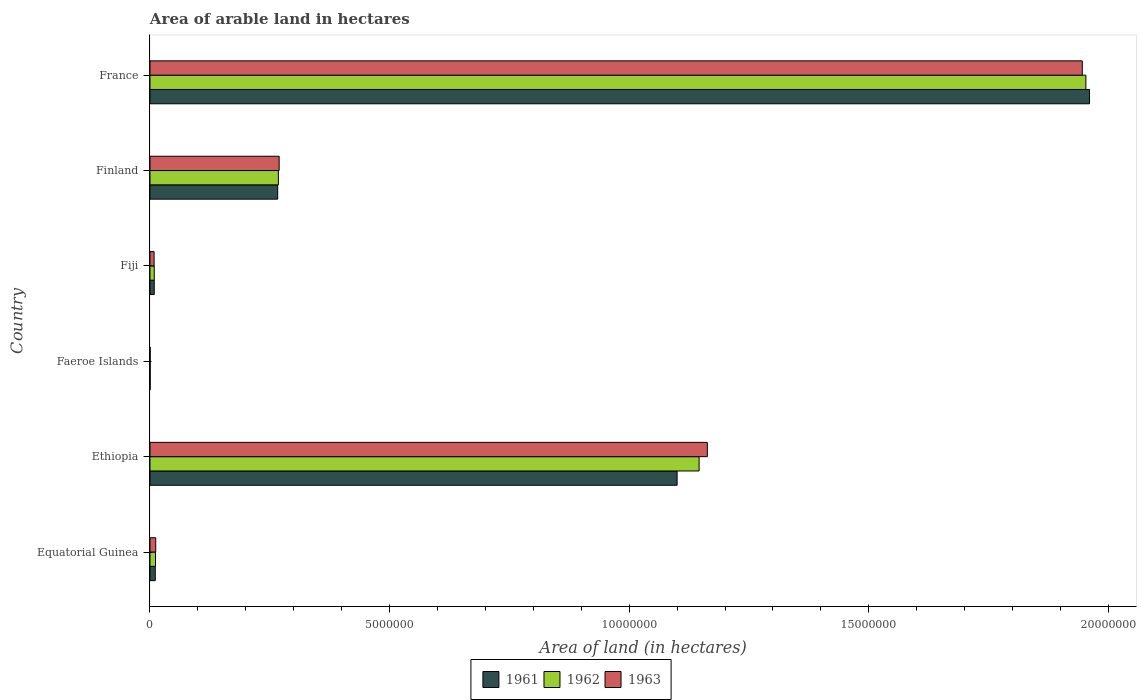How many different coloured bars are there?
Your answer should be compact. 3. How many groups of bars are there?
Provide a short and direct response. 6. Are the number of bars per tick equal to the number of legend labels?
Provide a succinct answer. Yes. Are the number of bars on each tick of the Y-axis equal?
Keep it short and to the point. Yes. How many bars are there on the 3rd tick from the top?
Provide a succinct answer. 3. How many bars are there on the 4th tick from the bottom?
Give a very brief answer. 3. What is the label of the 6th group of bars from the top?
Provide a short and direct response. Equatorial Guinea. What is the total arable land in 1962 in France?
Ensure brevity in your answer.  1.95e+07. Across all countries, what is the maximum total arable land in 1962?
Make the answer very short. 1.95e+07. Across all countries, what is the minimum total arable land in 1962?
Keep it short and to the point. 3000. In which country was the total arable land in 1962 minimum?
Offer a terse response. Faeroe Islands. What is the total total arable land in 1963 in the graph?
Offer a very short reply. 3.40e+07. What is the difference between the total arable land in 1963 in Equatorial Guinea and that in Finland?
Provide a short and direct response. -2.58e+06. What is the difference between the total arable land in 1963 in Fiji and the total arable land in 1961 in Finland?
Your answer should be compact. -2.58e+06. What is the average total arable land in 1963 per country?
Offer a very short reply. 5.67e+06. What is the difference between the total arable land in 1963 and total arable land in 1962 in France?
Your response must be concise. -7.50e+04. What is the ratio of the total arable land in 1963 in Fiji to that in France?
Offer a very short reply. 0. Is the total arable land in 1962 in Equatorial Guinea less than that in Fiji?
Provide a short and direct response. No. What is the difference between the highest and the second highest total arable land in 1962?
Ensure brevity in your answer.  8.07e+06. What is the difference between the highest and the lowest total arable land in 1963?
Provide a succinct answer. 1.95e+07. In how many countries, is the total arable land in 1961 greater than the average total arable land in 1961 taken over all countries?
Your response must be concise. 2. Is the sum of the total arable land in 1961 in Ethiopia and Faeroe Islands greater than the maximum total arable land in 1962 across all countries?
Offer a terse response. No. What does the 3rd bar from the top in Faeroe Islands represents?
Your answer should be very brief. 1961. Are all the bars in the graph horizontal?
Your answer should be very brief. Yes. How many countries are there in the graph?
Make the answer very short. 6. Are the values on the major ticks of X-axis written in scientific E-notation?
Your response must be concise. No. Does the graph contain any zero values?
Provide a short and direct response. No. Where does the legend appear in the graph?
Offer a terse response. Bottom center. How many legend labels are there?
Provide a succinct answer. 3. What is the title of the graph?
Keep it short and to the point. Area of arable land in hectares. Does "2005" appear as one of the legend labels in the graph?
Your answer should be very brief. No. What is the label or title of the X-axis?
Make the answer very short. Area of land (in hectares). What is the label or title of the Y-axis?
Provide a succinct answer. Country. What is the Area of land (in hectares) in 1961 in Equatorial Guinea?
Offer a very short reply. 1.10e+05. What is the Area of land (in hectares) of 1962 in Equatorial Guinea?
Keep it short and to the point. 1.15e+05. What is the Area of land (in hectares) of 1963 in Equatorial Guinea?
Offer a very short reply. 1.20e+05. What is the Area of land (in hectares) of 1961 in Ethiopia?
Make the answer very short. 1.10e+07. What is the Area of land (in hectares) of 1962 in Ethiopia?
Offer a terse response. 1.15e+07. What is the Area of land (in hectares) of 1963 in Ethiopia?
Offer a very short reply. 1.16e+07. What is the Area of land (in hectares) of 1961 in Faeroe Islands?
Your response must be concise. 3000. What is the Area of land (in hectares) of 1962 in Faeroe Islands?
Provide a succinct answer. 3000. What is the Area of land (in hectares) in 1963 in Faeroe Islands?
Your answer should be very brief. 3000. What is the Area of land (in hectares) in 1961 in Fiji?
Your response must be concise. 8.90e+04. What is the Area of land (in hectares) of 1962 in Fiji?
Provide a succinct answer. 8.90e+04. What is the Area of land (in hectares) of 1963 in Fiji?
Ensure brevity in your answer.  8.60e+04. What is the Area of land (in hectares) of 1961 in Finland?
Provide a succinct answer. 2.66e+06. What is the Area of land (in hectares) in 1962 in Finland?
Ensure brevity in your answer.  2.68e+06. What is the Area of land (in hectares) of 1963 in Finland?
Provide a succinct answer. 2.70e+06. What is the Area of land (in hectares) in 1961 in France?
Your answer should be very brief. 1.96e+07. What is the Area of land (in hectares) in 1962 in France?
Your answer should be very brief. 1.95e+07. What is the Area of land (in hectares) of 1963 in France?
Give a very brief answer. 1.95e+07. Across all countries, what is the maximum Area of land (in hectares) of 1961?
Ensure brevity in your answer.  1.96e+07. Across all countries, what is the maximum Area of land (in hectares) in 1962?
Give a very brief answer. 1.95e+07. Across all countries, what is the maximum Area of land (in hectares) in 1963?
Your answer should be compact. 1.95e+07. Across all countries, what is the minimum Area of land (in hectares) in 1961?
Your response must be concise. 3000. Across all countries, what is the minimum Area of land (in hectares) in 1962?
Your answer should be very brief. 3000. Across all countries, what is the minimum Area of land (in hectares) of 1963?
Keep it short and to the point. 3000. What is the total Area of land (in hectares) of 1961 in the graph?
Keep it short and to the point. 3.35e+07. What is the total Area of land (in hectares) of 1962 in the graph?
Provide a succinct answer. 3.39e+07. What is the total Area of land (in hectares) in 1963 in the graph?
Provide a succinct answer. 3.40e+07. What is the difference between the Area of land (in hectares) in 1961 in Equatorial Guinea and that in Ethiopia?
Provide a short and direct response. -1.09e+07. What is the difference between the Area of land (in hectares) of 1962 in Equatorial Guinea and that in Ethiopia?
Offer a very short reply. -1.13e+07. What is the difference between the Area of land (in hectares) of 1963 in Equatorial Guinea and that in Ethiopia?
Give a very brief answer. -1.15e+07. What is the difference between the Area of land (in hectares) in 1961 in Equatorial Guinea and that in Faeroe Islands?
Offer a terse response. 1.07e+05. What is the difference between the Area of land (in hectares) of 1962 in Equatorial Guinea and that in Faeroe Islands?
Your answer should be very brief. 1.12e+05. What is the difference between the Area of land (in hectares) of 1963 in Equatorial Guinea and that in Faeroe Islands?
Your answer should be very brief. 1.17e+05. What is the difference between the Area of land (in hectares) of 1961 in Equatorial Guinea and that in Fiji?
Your response must be concise. 2.10e+04. What is the difference between the Area of land (in hectares) in 1962 in Equatorial Guinea and that in Fiji?
Offer a very short reply. 2.60e+04. What is the difference between the Area of land (in hectares) in 1963 in Equatorial Guinea and that in Fiji?
Ensure brevity in your answer.  3.40e+04. What is the difference between the Area of land (in hectares) in 1961 in Equatorial Guinea and that in Finland?
Offer a very short reply. -2.55e+06. What is the difference between the Area of land (in hectares) in 1962 in Equatorial Guinea and that in Finland?
Make the answer very short. -2.56e+06. What is the difference between the Area of land (in hectares) in 1963 in Equatorial Guinea and that in Finland?
Make the answer very short. -2.58e+06. What is the difference between the Area of land (in hectares) of 1961 in Equatorial Guinea and that in France?
Offer a terse response. -1.95e+07. What is the difference between the Area of land (in hectares) in 1962 in Equatorial Guinea and that in France?
Your answer should be compact. -1.94e+07. What is the difference between the Area of land (in hectares) in 1963 in Equatorial Guinea and that in France?
Give a very brief answer. -1.93e+07. What is the difference between the Area of land (in hectares) in 1961 in Ethiopia and that in Faeroe Islands?
Give a very brief answer. 1.10e+07. What is the difference between the Area of land (in hectares) in 1962 in Ethiopia and that in Faeroe Islands?
Provide a succinct answer. 1.15e+07. What is the difference between the Area of land (in hectares) in 1963 in Ethiopia and that in Faeroe Islands?
Offer a very short reply. 1.16e+07. What is the difference between the Area of land (in hectares) of 1961 in Ethiopia and that in Fiji?
Your answer should be very brief. 1.09e+07. What is the difference between the Area of land (in hectares) in 1962 in Ethiopia and that in Fiji?
Your answer should be compact. 1.14e+07. What is the difference between the Area of land (in hectares) of 1963 in Ethiopia and that in Fiji?
Ensure brevity in your answer.  1.15e+07. What is the difference between the Area of land (in hectares) of 1961 in Ethiopia and that in Finland?
Offer a terse response. 8.34e+06. What is the difference between the Area of land (in hectares) in 1962 in Ethiopia and that in Finland?
Offer a very short reply. 8.78e+06. What is the difference between the Area of land (in hectares) in 1963 in Ethiopia and that in Finland?
Keep it short and to the point. 8.94e+06. What is the difference between the Area of land (in hectares) of 1961 in Ethiopia and that in France?
Provide a succinct answer. -8.61e+06. What is the difference between the Area of land (in hectares) in 1962 in Ethiopia and that in France?
Offer a very short reply. -8.07e+06. What is the difference between the Area of land (in hectares) in 1963 in Ethiopia and that in France?
Ensure brevity in your answer.  -7.82e+06. What is the difference between the Area of land (in hectares) of 1961 in Faeroe Islands and that in Fiji?
Your answer should be compact. -8.60e+04. What is the difference between the Area of land (in hectares) in 1962 in Faeroe Islands and that in Fiji?
Give a very brief answer. -8.60e+04. What is the difference between the Area of land (in hectares) of 1963 in Faeroe Islands and that in Fiji?
Provide a succinct answer. -8.30e+04. What is the difference between the Area of land (in hectares) of 1961 in Faeroe Islands and that in Finland?
Your answer should be very brief. -2.66e+06. What is the difference between the Area of land (in hectares) in 1962 in Faeroe Islands and that in Finland?
Provide a short and direct response. -2.68e+06. What is the difference between the Area of land (in hectares) of 1963 in Faeroe Islands and that in Finland?
Offer a terse response. -2.69e+06. What is the difference between the Area of land (in hectares) in 1961 in Faeroe Islands and that in France?
Offer a terse response. -1.96e+07. What is the difference between the Area of land (in hectares) in 1962 in Faeroe Islands and that in France?
Give a very brief answer. -1.95e+07. What is the difference between the Area of land (in hectares) of 1963 in Faeroe Islands and that in France?
Provide a short and direct response. -1.95e+07. What is the difference between the Area of land (in hectares) in 1961 in Fiji and that in Finland?
Your answer should be very brief. -2.58e+06. What is the difference between the Area of land (in hectares) in 1962 in Fiji and that in Finland?
Your response must be concise. -2.59e+06. What is the difference between the Area of land (in hectares) of 1963 in Fiji and that in Finland?
Your answer should be compact. -2.61e+06. What is the difference between the Area of land (in hectares) in 1961 in Fiji and that in France?
Your answer should be compact. -1.95e+07. What is the difference between the Area of land (in hectares) of 1962 in Fiji and that in France?
Provide a succinct answer. -1.94e+07. What is the difference between the Area of land (in hectares) in 1963 in Fiji and that in France?
Your response must be concise. -1.94e+07. What is the difference between the Area of land (in hectares) of 1961 in Finland and that in France?
Ensure brevity in your answer.  -1.69e+07. What is the difference between the Area of land (in hectares) of 1962 in Finland and that in France?
Your answer should be very brief. -1.69e+07. What is the difference between the Area of land (in hectares) of 1963 in Finland and that in France?
Make the answer very short. -1.68e+07. What is the difference between the Area of land (in hectares) of 1961 in Equatorial Guinea and the Area of land (in hectares) of 1962 in Ethiopia?
Make the answer very short. -1.13e+07. What is the difference between the Area of land (in hectares) of 1961 in Equatorial Guinea and the Area of land (in hectares) of 1963 in Ethiopia?
Your answer should be very brief. -1.15e+07. What is the difference between the Area of land (in hectares) of 1962 in Equatorial Guinea and the Area of land (in hectares) of 1963 in Ethiopia?
Provide a short and direct response. -1.15e+07. What is the difference between the Area of land (in hectares) of 1961 in Equatorial Guinea and the Area of land (in hectares) of 1962 in Faeroe Islands?
Keep it short and to the point. 1.07e+05. What is the difference between the Area of land (in hectares) in 1961 in Equatorial Guinea and the Area of land (in hectares) in 1963 in Faeroe Islands?
Your response must be concise. 1.07e+05. What is the difference between the Area of land (in hectares) in 1962 in Equatorial Guinea and the Area of land (in hectares) in 1963 in Faeroe Islands?
Provide a succinct answer. 1.12e+05. What is the difference between the Area of land (in hectares) in 1961 in Equatorial Guinea and the Area of land (in hectares) in 1962 in Fiji?
Your answer should be very brief. 2.10e+04. What is the difference between the Area of land (in hectares) in 1961 in Equatorial Guinea and the Area of land (in hectares) in 1963 in Fiji?
Provide a short and direct response. 2.40e+04. What is the difference between the Area of land (in hectares) of 1962 in Equatorial Guinea and the Area of land (in hectares) of 1963 in Fiji?
Give a very brief answer. 2.90e+04. What is the difference between the Area of land (in hectares) in 1961 in Equatorial Guinea and the Area of land (in hectares) in 1962 in Finland?
Your answer should be very brief. -2.57e+06. What is the difference between the Area of land (in hectares) in 1961 in Equatorial Guinea and the Area of land (in hectares) in 1963 in Finland?
Ensure brevity in your answer.  -2.59e+06. What is the difference between the Area of land (in hectares) in 1962 in Equatorial Guinea and the Area of land (in hectares) in 1963 in Finland?
Your answer should be very brief. -2.58e+06. What is the difference between the Area of land (in hectares) in 1961 in Equatorial Guinea and the Area of land (in hectares) in 1962 in France?
Give a very brief answer. -1.94e+07. What is the difference between the Area of land (in hectares) in 1961 in Equatorial Guinea and the Area of land (in hectares) in 1963 in France?
Make the answer very short. -1.93e+07. What is the difference between the Area of land (in hectares) of 1962 in Equatorial Guinea and the Area of land (in hectares) of 1963 in France?
Offer a very short reply. -1.93e+07. What is the difference between the Area of land (in hectares) of 1961 in Ethiopia and the Area of land (in hectares) of 1962 in Faeroe Islands?
Make the answer very short. 1.10e+07. What is the difference between the Area of land (in hectares) of 1961 in Ethiopia and the Area of land (in hectares) of 1963 in Faeroe Islands?
Your answer should be very brief. 1.10e+07. What is the difference between the Area of land (in hectares) in 1962 in Ethiopia and the Area of land (in hectares) in 1963 in Faeroe Islands?
Your answer should be very brief. 1.15e+07. What is the difference between the Area of land (in hectares) in 1961 in Ethiopia and the Area of land (in hectares) in 1962 in Fiji?
Your answer should be very brief. 1.09e+07. What is the difference between the Area of land (in hectares) of 1961 in Ethiopia and the Area of land (in hectares) of 1963 in Fiji?
Offer a terse response. 1.09e+07. What is the difference between the Area of land (in hectares) of 1962 in Ethiopia and the Area of land (in hectares) of 1963 in Fiji?
Provide a short and direct response. 1.14e+07. What is the difference between the Area of land (in hectares) of 1961 in Ethiopia and the Area of land (in hectares) of 1962 in Finland?
Ensure brevity in your answer.  8.32e+06. What is the difference between the Area of land (in hectares) in 1961 in Ethiopia and the Area of land (in hectares) in 1963 in Finland?
Ensure brevity in your answer.  8.30e+06. What is the difference between the Area of land (in hectares) of 1962 in Ethiopia and the Area of land (in hectares) of 1963 in Finland?
Your answer should be very brief. 8.76e+06. What is the difference between the Area of land (in hectares) of 1961 in Ethiopia and the Area of land (in hectares) of 1962 in France?
Ensure brevity in your answer.  -8.53e+06. What is the difference between the Area of land (in hectares) in 1961 in Ethiopia and the Area of land (in hectares) in 1963 in France?
Your answer should be compact. -8.46e+06. What is the difference between the Area of land (in hectares) of 1962 in Ethiopia and the Area of land (in hectares) of 1963 in France?
Your answer should be very brief. -8.00e+06. What is the difference between the Area of land (in hectares) in 1961 in Faeroe Islands and the Area of land (in hectares) in 1962 in Fiji?
Your response must be concise. -8.60e+04. What is the difference between the Area of land (in hectares) in 1961 in Faeroe Islands and the Area of land (in hectares) in 1963 in Fiji?
Provide a short and direct response. -8.30e+04. What is the difference between the Area of land (in hectares) in 1962 in Faeroe Islands and the Area of land (in hectares) in 1963 in Fiji?
Keep it short and to the point. -8.30e+04. What is the difference between the Area of land (in hectares) of 1961 in Faeroe Islands and the Area of land (in hectares) of 1962 in Finland?
Offer a very short reply. -2.68e+06. What is the difference between the Area of land (in hectares) of 1961 in Faeroe Islands and the Area of land (in hectares) of 1963 in Finland?
Ensure brevity in your answer.  -2.69e+06. What is the difference between the Area of land (in hectares) of 1962 in Faeroe Islands and the Area of land (in hectares) of 1963 in Finland?
Offer a terse response. -2.69e+06. What is the difference between the Area of land (in hectares) in 1961 in Faeroe Islands and the Area of land (in hectares) in 1962 in France?
Make the answer very short. -1.95e+07. What is the difference between the Area of land (in hectares) of 1961 in Faeroe Islands and the Area of land (in hectares) of 1963 in France?
Ensure brevity in your answer.  -1.95e+07. What is the difference between the Area of land (in hectares) of 1962 in Faeroe Islands and the Area of land (in hectares) of 1963 in France?
Offer a very short reply. -1.95e+07. What is the difference between the Area of land (in hectares) in 1961 in Fiji and the Area of land (in hectares) in 1962 in Finland?
Ensure brevity in your answer.  -2.59e+06. What is the difference between the Area of land (in hectares) of 1961 in Fiji and the Area of land (in hectares) of 1963 in Finland?
Your response must be concise. -2.61e+06. What is the difference between the Area of land (in hectares) of 1962 in Fiji and the Area of land (in hectares) of 1963 in Finland?
Give a very brief answer. -2.61e+06. What is the difference between the Area of land (in hectares) in 1961 in Fiji and the Area of land (in hectares) in 1962 in France?
Provide a succinct answer. -1.94e+07. What is the difference between the Area of land (in hectares) in 1961 in Fiji and the Area of land (in hectares) in 1963 in France?
Ensure brevity in your answer.  -1.94e+07. What is the difference between the Area of land (in hectares) of 1962 in Fiji and the Area of land (in hectares) of 1963 in France?
Provide a succinct answer. -1.94e+07. What is the difference between the Area of land (in hectares) of 1961 in Finland and the Area of land (in hectares) of 1962 in France?
Provide a succinct answer. -1.69e+07. What is the difference between the Area of land (in hectares) in 1961 in Finland and the Area of land (in hectares) in 1963 in France?
Keep it short and to the point. -1.68e+07. What is the difference between the Area of land (in hectares) in 1962 in Finland and the Area of land (in hectares) in 1963 in France?
Ensure brevity in your answer.  -1.68e+07. What is the average Area of land (in hectares) in 1961 per country?
Offer a very short reply. 5.58e+06. What is the average Area of land (in hectares) in 1962 per country?
Provide a short and direct response. 5.65e+06. What is the average Area of land (in hectares) in 1963 per country?
Your answer should be very brief. 5.67e+06. What is the difference between the Area of land (in hectares) in 1961 and Area of land (in hectares) in 1962 in Equatorial Guinea?
Keep it short and to the point. -5000. What is the difference between the Area of land (in hectares) of 1961 and Area of land (in hectares) of 1963 in Equatorial Guinea?
Provide a succinct answer. -10000. What is the difference between the Area of land (in hectares) in 1962 and Area of land (in hectares) in 1963 in Equatorial Guinea?
Make the answer very short. -5000. What is the difference between the Area of land (in hectares) of 1961 and Area of land (in hectares) of 1962 in Ethiopia?
Make the answer very short. -4.59e+05. What is the difference between the Area of land (in hectares) of 1961 and Area of land (in hectares) of 1963 in Ethiopia?
Keep it short and to the point. -6.31e+05. What is the difference between the Area of land (in hectares) of 1962 and Area of land (in hectares) of 1963 in Ethiopia?
Offer a very short reply. -1.72e+05. What is the difference between the Area of land (in hectares) in 1962 and Area of land (in hectares) in 1963 in Faeroe Islands?
Offer a very short reply. 0. What is the difference between the Area of land (in hectares) in 1961 and Area of land (in hectares) in 1962 in Fiji?
Make the answer very short. 0. What is the difference between the Area of land (in hectares) in 1961 and Area of land (in hectares) in 1963 in Fiji?
Offer a terse response. 3000. What is the difference between the Area of land (in hectares) of 1962 and Area of land (in hectares) of 1963 in Fiji?
Keep it short and to the point. 3000. What is the difference between the Area of land (in hectares) in 1961 and Area of land (in hectares) in 1962 in Finland?
Your response must be concise. -1.44e+04. What is the difference between the Area of land (in hectares) of 1961 and Area of land (in hectares) of 1963 in Finland?
Your answer should be compact. -3.08e+04. What is the difference between the Area of land (in hectares) of 1962 and Area of land (in hectares) of 1963 in Finland?
Your answer should be compact. -1.64e+04. What is the difference between the Area of land (in hectares) in 1961 and Area of land (in hectares) in 1962 in France?
Your answer should be compact. 7.60e+04. What is the difference between the Area of land (in hectares) in 1961 and Area of land (in hectares) in 1963 in France?
Offer a terse response. 1.51e+05. What is the difference between the Area of land (in hectares) in 1962 and Area of land (in hectares) in 1963 in France?
Offer a very short reply. 7.50e+04. What is the ratio of the Area of land (in hectares) in 1961 in Equatorial Guinea to that in Ethiopia?
Keep it short and to the point. 0.01. What is the ratio of the Area of land (in hectares) in 1963 in Equatorial Guinea to that in Ethiopia?
Offer a terse response. 0.01. What is the ratio of the Area of land (in hectares) in 1961 in Equatorial Guinea to that in Faeroe Islands?
Your answer should be very brief. 36.67. What is the ratio of the Area of land (in hectares) of 1962 in Equatorial Guinea to that in Faeroe Islands?
Your answer should be compact. 38.33. What is the ratio of the Area of land (in hectares) in 1961 in Equatorial Guinea to that in Fiji?
Offer a very short reply. 1.24. What is the ratio of the Area of land (in hectares) of 1962 in Equatorial Guinea to that in Fiji?
Provide a short and direct response. 1.29. What is the ratio of the Area of land (in hectares) of 1963 in Equatorial Guinea to that in Fiji?
Your answer should be compact. 1.4. What is the ratio of the Area of land (in hectares) of 1961 in Equatorial Guinea to that in Finland?
Ensure brevity in your answer.  0.04. What is the ratio of the Area of land (in hectares) in 1962 in Equatorial Guinea to that in Finland?
Offer a very short reply. 0.04. What is the ratio of the Area of land (in hectares) in 1963 in Equatorial Guinea to that in Finland?
Keep it short and to the point. 0.04. What is the ratio of the Area of land (in hectares) in 1961 in Equatorial Guinea to that in France?
Your answer should be compact. 0.01. What is the ratio of the Area of land (in hectares) in 1962 in Equatorial Guinea to that in France?
Provide a short and direct response. 0.01. What is the ratio of the Area of land (in hectares) of 1963 in Equatorial Guinea to that in France?
Give a very brief answer. 0.01. What is the ratio of the Area of land (in hectares) in 1961 in Ethiopia to that in Faeroe Islands?
Your answer should be compact. 3666.67. What is the ratio of the Area of land (in hectares) in 1962 in Ethiopia to that in Faeroe Islands?
Offer a very short reply. 3819.67. What is the ratio of the Area of land (in hectares) of 1963 in Ethiopia to that in Faeroe Islands?
Keep it short and to the point. 3877. What is the ratio of the Area of land (in hectares) of 1961 in Ethiopia to that in Fiji?
Keep it short and to the point. 123.6. What is the ratio of the Area of land (in hectares) in 1962 in Ethiopia to that in Fiji?
Provide a short and direct response. 128.75. What is the ratio of the Area of land (in hectares) of 1963 in Ethiopia to that in Fiji?
Offer a very short reply. 135.24. What is the ratio of the Area of land (in hectares) of 1961 in Ethiopia to that in Finland?
Offer a terse response. 4.13. What is the ratio of the Area of land (in hectares) in 1962 in Ethiopia to that in Finland?
Make the answer very short. 4.28. What is the ratio of the Area of land (in hectares) of 1963 in Ethiopia to that in Finland?
Offer a terse response. 4.32. What is the ratio of the Area of land (in hectares) of 1961 in Ethiopia to that in France?
Keep it short and to the point. 0.56. What is the ratio of the Area of land (in hectares) of 1962 in Ethiopia to that in France?
Your answer should be compact. 0.59. What is the ratio of the Area of land (in hectares) in 1963 in Ethiopia to that in France?
Your answer should be compact. 0.6. What is the ratio of the Area of land (in hectares) of 1961 in Faeroe Islands to that in Fiji?
Offer a terse response. 0.03. What is the ratio of the Area of land (in hectares) in 1962 in Faeroe Islands to that in Fiji?
Your response must be concise. 0.03. What is the ratio of the Area of land (in hectares) of 1963 in Faeroe Islands to that in Fiji?
Your answer should be very brief. 0.03. What is the ratio of the Area of land (in hectares) in 1961 in Faeroe Islands to that in Finland?
Your response must be concise. 0. What is the ratio of the Area of land (in hectares) in 1962 in Faeroe Islands to that in Finland?
Offer a very short reply. 0. What is the ratio of the Area of land (in hectares) in 1963 in Faeroe Islands to that in Finland?
Your response must be concise. 0. What is the ratio of the Area of land (in hectares) in 1961 in Faeroe Islands to that in France?
Give a very brief answer. 0. What is the ratio of the Area of land (in hectares) in 1963 in Faeroe Islands to that in France?
Provide a succinct answer. 0. What is the ratio of the Area of land (in hectares) in 1961 in Fiji to that in Finland?
Offer a very short reply. 0.03. What is the ratio of the Area of land (in hectares) in 1962 in Fiji to that in Finland?
Keep it short and to the point. 0.03. What is the ratio of the Area of land (in hectares) in 1963 in Fiji to that in Finland?
Provide a short and direct response. 0.03. What is the ratio of the Area of land (in hectares) of 1961 in Fiji to that in France?
Offer a terse response. 0. What is the ratio of the Area of land (in hectares) in 1962 in Fiji to that in France?
Your response must be concise. 0. What is the ratio of the Area of land (in hectares) in 1963 in Fiji to that in France?
Your answer should be compact. 0. What is the ratio of the Area of land (in hectares) in 1961 in Finland to that in France?
Your response must be concise. 0.14. What is the ratio of the Area of land (in hectares) in 1962 in Finland to that in France?
Ensure brevity in your answer.  0.14. What is the ratio of the Area of land (in hectares) in 1963 in Finland to that in France?
Provide a succinct answer. 0.14. What is the difference between the highest and the second highest Area of land (in hectares) in 1961?
Provide a succinct answer. 8.61e+06. What is the difference between the highest and the second highest Area of land (in hectares) of 1962?
Your response must be concise. 8.07e+06. What is the difference between the highest and the second highest Area of land (in hectares) in 1963?
Make the answer very short. 7.82e+06. What is the difference between the highest and the lowest Area of land (in hectares) of 1961?
Your response must be concise. 1.96e+07. What is the difference between the highest and the lowest Area of land (in hectares) of 1962?
Make the answer very short. 1.95e+07. What is the difference between the highest and the lowest Area of land (in hectares) in 1963?
Your response must be concise. 1.95e+07. 